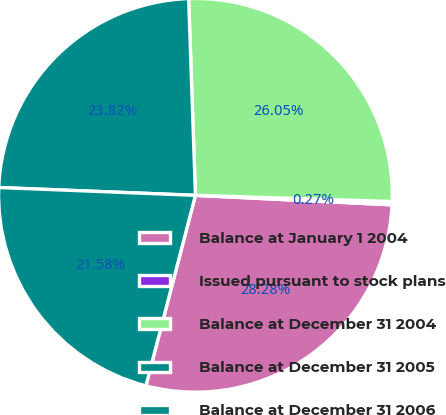Convert chart to OTSL. <chart><loc_0><loc_0><loc_500><loc_500><pie_chart><fcel>Balance at January 1 2004<fcel>Issued pursuant to stock plans<fcel>Balance at December 31 2004<fcel>Balance at December 31 2005<fcel>Balance at December 31 2006<nl><fcel>28.28%<fcel>0.27%<fcel>26.05%<fcel>23.82%<fcel>21.58%<nl></chart> 